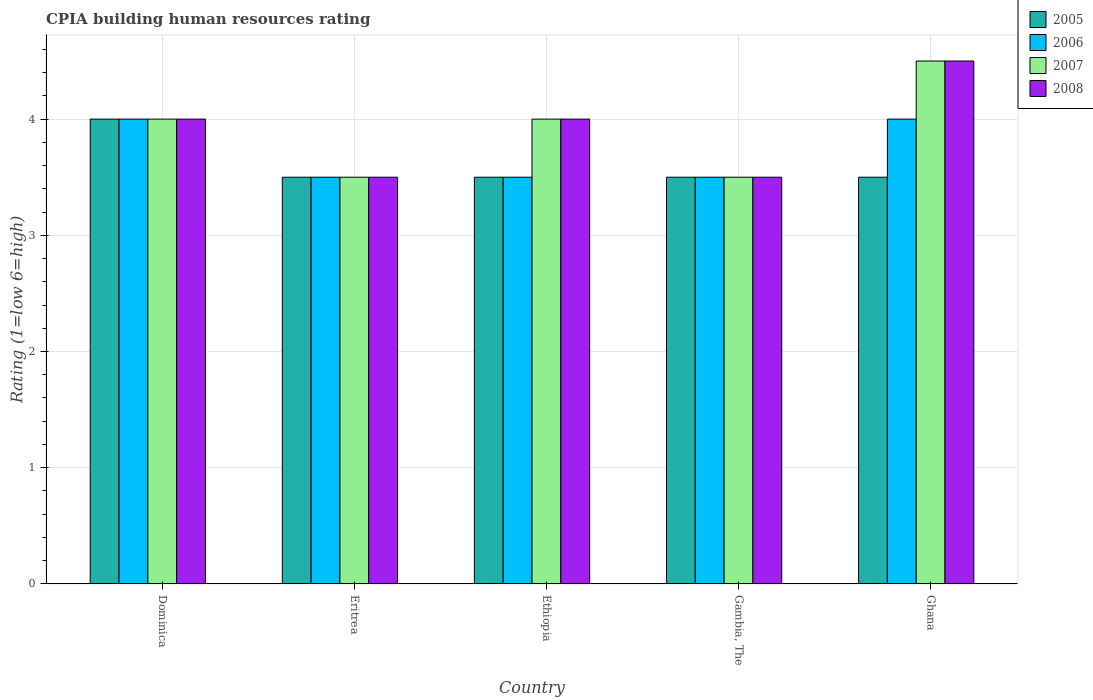Are the number of bars per tick equal to the number of legend labels?
Your answer should be compact. Yes. What is the label of the 5th group of bars from the left?
Provide a short and direct response. Ghana. What is the CPIA rating in 2005 in Ghana?
Give a very brief answer. 3.5. Across all countries, what is the maximum CPIA rating in 2008?
Give a very brief answer. 4.5. Across all countries, what is the minimum CPIA rating in 2005?
Provide a short and direct response. 3.5. In which country was the CPIA rating in 2006 maximum?
Provide a short and direct response. Dominica. In which country was the CPIA rating in 2005 minimum?
Provide a succinct answer. Eritrea. What is the average CPIA rating in 2007 per country?
Offer a terse response. 3.9. What is the difference between the CPIA rating of/in 2006 and CPIA rating of/in 2007 in Eritrea?
Provide a succinct answer. 0. In how many countries, is the CPIA rating in 2006 greater than 2.8?
Provide a succinct answer. 5. What is the ratio of the CPIA rating in 2007 in Ethiopia to that in Ghana?
Your answer should be very brief. 0.89. Is the CPIA rating in 2006 in Dominica less than that in Ghana?
Keep it short and to the point. No. Is the difference between the CPIA rating in 2006 in Ethiopia and Ghana greater than the difference between the CPIA rating in 2007 in Ethiopia and Ghana?
Give a very brief answer. No. What is the difference between the highest and the second highest CPIA rating in 2007?
Your answer should be very brief. 0.5. Is the sum of the CPIA rating in 2005 in Dominica and Ethiopia greater than the maximum CPIA rating in 2008 across all countries?
Make the answer very short. Yes. Is it the case that in every country, the sum of the CPIA rating in 2007 and CPIA rating in 2005 is greater than the sum of CPIA rating in 2006 and CPIA rating in 2008?
Provide a short and direct response. No. What does the 2nd bar from the right in Ghana represents?
Your response must be concise. 2007. Is it the case that in every country, the sum of the CPIA rating in 2006 and CPIA rating in 2005 is greater than the CPIA rating in 2007?
Make the answer very short. Yes. What is the difference between two consecutive major ticks on the Y-axis?
Your response must be concise. 1. Are the values on the major ticks of Y-axis written in scientific E-notation?
Your answer should be compact. No. Does the graph contain any zero values?
Keep it short and to the point. No. How many legend labels are there?
Your answer should be compact. 4. How are the legend labels stacked?
Give a very brief answer. Vertical. What is the title of the graph?
Give a very brief answer. CPIA building human resources rating. Does "1992" appear as one of the legend labels in the graph?
Keep it short and to the point. No. What is the label or title of the X-axis?
Give a very brief answer. Country. What is the Rating (1=low 6=high) of 2006 in Dominica?
Provide a short and direct response. 4. What is the Rating (1=low 6=high) in 2008 in Dominica?
Make the answer very short. 4. What is the Rating (1=low 6=high) in 2005 in Eritrea?
Give a very brief answer. 3.5. What is the Rating (1=low 6=high) of 2008 in Eritrea?
Ensure brevity in your answer.  3.5. What is the Rating (1=low 6=high) of 2005 in Ethiopia?
Your answer should be very brief. 3.5. What is the Rating (1=low 6=high) of 2006 in Ethiopia?
Provide a succinct answer. 3.5. What is the Rating (1=low 6=high) of 2007 in Ethiopia?
Give a very brief answer. 4. What is the Rating (1=low 6=high) of 2008 in Ethiopia?
Your answer should be compact. 4. What is the Rating (1=low 6=high) in 2006 in Ghana?
Offer a terse response. 4. Across all countries, what is the maximum Rating (1=low 6=high) in 2005?
Ensure brevity in your answer.  4. Across all countries, what is the maximum Rating (1=low 6=high) in 2006?
Keep it short and to the point. 4. Across all countries, what is the maximum Rating (1=low 6=high) in 2007?
Ensure brevity in your answer.  4.5. Across all countries, what is the minimum Rating (1=low 6=high) of 2005?
Keep it short and to the point. 3.5. Across all countries, what is the minimum Rating (1=low 6=high) in 2006?
Make the answer very short. 3.5. Across all countries, what is the minimum Rating (1=low 6=high) of 2007?
Keep it short and to the point. 3.5. Across all countries, what is the minimum Rating (1=low 6=high) of 2008?
Your answer should be compact. 3.5. What is the total Rating (1=low 6=high) in 2005 in the graph?
Ensure brevity in your answer.  18. What is the total Rating (1=low 6=high) in 2006 in the graph?
Ensure brevity in your answer.  18.5. What is the total Rating (1=low 6=high) of 2007 in the graph?
Provide a short and direct response. 19.5. What is the total Rating (1=low 6=high) of 2008 in the graph?
Offer a terse response. 19.5. What is the difference between the Rating (1=low 6=high) of 2008 in Dominica and that in Eritrea?
Provide a succinct answer. 0.5. What is the difference between the Rating (1=low 6=high) in 2006 in Dominica and that in Ethiopia?
Offer a terse response. 0.5. What is the difference between the Rating (1=low 6=high) in 2007 in Dominica and that in Ethiopia?
Your response must be concise. 0. What is the difference between the Rating (1=low 6=high) in 2005 in Dominica and that in Gambia, The?
Your answer should be compact. 0.5. What is the difference between the Rating (1=low 6=high) in 2007 in Dominica and that in Gambia, The?
Provide a short and direct response. 0.5. What is the difference between the Rating (1=low 6=high) in 2005 in Dominica and that in Ghana?
Provide a succinct answer. 0.5. What is the difference between the Rating (1=low 6=high) of 2007 in Dominica and that in Ghana?
Your response must be concise. -0.5. What is the difference between the Rating (1=low 6=high) in 2008 in Dominica and that in Ghana?
Make the answer very short. -0.5. What is the difference between the Rating (1=low 6=high) in 2008 in Eritrea and that in Ethiopia?
Ensure brevity in your answer.  -0.5. What is the difference between the Rating (1=low 6=high) in 2005 in Eritrea and that in Ghana?
Ensure brevity in your answer.  0. What is the difference between the Rating (1=low 6=high) in 2006 in Eritrea and that in Ghana?
Your response must be concise. -0.5. What is the difference between the Rating (1=low 6=high) in 2007 in Eritrea and that in Ghana?
Offer a very short reply. -1. What is the difference between the Rating (1=low 6=high) of 2006 in Ethiopia and that in Gambia, The?
Keep it short and to the point. 0. What is the difference between the Rating (1=low 6=high) in 2008 in Ethiopia and that in Gambia, The?
Give a very brief answer. 0.5. What is the difference between the Rating (1=low 6=high) in 2006 in Ethiopia and that in Ghana?
Provide a short and direct response. -0.5. What is the difference between the Rating (1=low 6=high) of 2008 in Ethiopia and that in Ghana?
Ensure brevity in your answer.  -0.5. What is the difference between the Rating (1=low 6=high) in 2006 in Gambia, The and that in Ghana?
Provide a short and direct response. -0.5. What is the difference between the Rating (1=low 6=high) of 2006 in Dominica and the Rating (1=low 6=high) of 2008 in Eritrea?
Keep it short and to the point. 0.5. What is the difference between the Rating (1=low 6=high) in 2005 in Dominica and the Rating (1=low 6=high) in 2007 in Ethiopia?
Provide a short and direct response. 0. What is the difference between the Rating (1=low 6=high) of 2006 in Dominica and the Rating (1=low 6=high) of 2008 in Ethiopia?
Your response must be concise. 0. What is the difference between the Rating (1=low 6=high) of 2007 in Dominica and the Rating (1=low 6=high) of 2008 in Ethiopia?
Keep it short and to the point. 0. What is the difference between the Rating (1=low 6=high) of 2005 in Dominica and the Rating (1=low 6=high) of 2008 in Gambia, The?
Keep it short and to the point. 0.5. What is the difference between the Rating (1=low 6=high) in 2005 in Dominica and the Rating (1=low 6=high) in 2007 in Ghana?
Your answer should be compact. -0.5. What is the difference between the Rating (1=low 6=high) of 2005 in Eritrea and the Rating (1=low 6=high) of 2006 in Ethiopia?
Ensure brevity in your answer.  0. What is the difference between the Rating (1=low 6=high) of 2006 in Eritrea and the Rating (1=low 6=high) of 2007 in Ethiopia?
Keep it short and to the point. -0.5. What is the difference between the Rating (1=low 6=high) in 2006 in Eritrea and the Rating (1=low 6=high) in 2008 in Ethiopia?
Provide a succinct answer. -0.5. What is the difference between the Rating (1=low 6=high) of 2007 in Eritrea and the Rating (1=low 6=high) of 2008 in Ethiopia?
Offer a terse response. -0.5. What is the difference between the Rating (1=low 6=high) in 2006 in Eritrea and the Rating (1=low 6=high) in 2007 in Gambia, The?
Your answer should be compact. 0. What is the difference between the Rating (1=low 6=high) in 2006 in Eritrea and the Rating (1=low 6=high) in 2008 in Gambia, The?
Provide a succinct answer. 0. What is the difference between the Rating (1=low 6=high) of 2005 in Ethiopia and the Rating (1=low 6=high) of 2006 in Gambia, The?
Give a very brief answer. 0. What is the difference between the Rating (1=low 6=high) of 2005 in Ethiopia and the Rating (1=low 6=high) of 2007 in Gambia, The?
Keep it short and to the point. 0. What is the difference between the Rating (1=low 6=high) of 2006 in Ethiopia and the Rating (1=low 6=high) of 2007 in Gambia, The?
Make the answer very short. 0. What is the difference between the Rating (1=low 6=high) of 2006 in Ethiopia and the Rating (1=low 6=high) of 2008 in Gambia, The?
Ensure brevity in your answer.  0. What is the difference between the Rating (1=low 6=high) in 2005 in Ethiopia and the Rating (1=low 6=high) in 2006 in Ghana?
Ensure brevity in your answer.  -0.5. What is the difference between the Rating (1=low 6=high) in 2005 in Ethiopia and the Rating (1=low 6=high) in 2008 in Ghana?
Provide a short and direct response. -1. What is the difference between the Rating (1=low 6=high) in 2006 in Ethiopia and the Rating (1=low 6=high) in 2007 in Ghana?
Your answer should be very brief. -1. What is the difference between the Rating (1=low 6=high) of 2005 in Gambia, The and the Rating (1=low 6=high) of 2007 in Ghana?
Your answer should be very brief. -1. What is the difference between the Rating (1=low 6=high) of 2005 in Gambia, The and the Rating (1=low 6=high) of 2008 in Ghana?
Provide a short and direct response. -1. What is the average Rating (1=low 6=high) of 2005 per country?
Your answer should be very brief. 3.6. What is the difference between the Rating (1=low 6=high) of 2005 and Rating (1=low 6=high) of 2006 in Dominica?
Offer a terse response. 0. What is the difference between the Rating (1=low 6=high) in 2005 and Rating (1=low 6=high) in 2008 in Dominica?
Your answer should be very brief. 0. What is the difference between the Rating (1=low 6=high) in 2007 and Rating (1=low 6=high) in 2008 in Dominica?
Your response must be concise. 0. What is the difference between the Rating (1=low 6=high) in 2005 and Rating (1=low 6=high) in 2006 in Eritrea?
Your answer should be compact. 0. What is the difference between the Rating (1=low 6=high) in 2005 and Rating (1=low 6=high) in 2007 in Eritrea?
Offer a very short reply. 0. What is the difference between the Rating (1=low 6=high) of 2006 and Rating (1=low 6=high) of 2008 in Eritrea?
Keep it short and to the point. 0. What is the difference between the Rating (1=low 6=high) in 2006 and Rating (1=low 6=high) in 2007 in Ethiopia?
Ensure brevity in your answer.  -0.5. What is the difference between the Rating (1=low 6=high) in 2005 and Rating (1=low 6=high) in 2007 in Gambia, The?
Provide a succinct answer. 0. What is the difference between the Rating (1=low 6=high) in 2005 and Rating (1=low 6=high) in 2008 in Gambia, The?
Ensure brevity in your answer.  0. What is the difference between the Rating (1=low 6=high) of 2007 and Rating (1=low 6=high) of 2008 in Gambia, The?
Offer a terse response. 0. What is the difference between the Rating (1=low 6=high) in 2005 and Rating (1=low 6=high) in 2007 in Ghana?
Give a very brief answer. -1. What is the difference between the Rating (1=low 6=high) of 2005 and Rating (1=low 6=high) of 2008 in Ghana?
Make the answer very short. -1. What is the difference between the Rating (1=low 6=high) of 2006 and Rating (1=low 6=high) of 2007 in Ghana?
Your answer should be very brief. -0.5. What is the difference between the Rating (1=low 6=high) in 2006 and Rating (1=low 6=high) in 2008 in Ghana?
Your answer should be very brief. -0.5. What is the ratio of the Rating (1=low 6=high) in 2005 in Dominica to that in Eritrea?
Make the answer very short. 1.14. What is the ratio of the Rating (1=low 6=high) of 2006 in Dominica to that in Eritrea?
Provide a short and direct response. 1.14. What is the ratio of the Rating (1=low 6=high) in 2005 in Dominica to that in Ethiopia?
Provide a short and direct response. 1.14. What is the ratio of the Rating (1=low 6=high) of 2008 in Dominica to that in Ethiopia?
Offer a terse response. 1. What is the ratio of the Rating (1=low 6=high) in 2006 in Dominica to that in Gambia, The?
Keep it short and to the point. 1.14. What is the ratio of the Rating (1=low 6=high) in 2008 in Dominica to that in Gambia, The?
Provide a succinct answer. 1.14. What is the ratio of the Rating (1=low 6=high) of 2005 in Dominica to that in Ghana?
Your answer should be very brief. 1.14. What is the ratio of the Rating (1=low 6=high) in 2006 in Dominica to that in Ghana?
Make the answer very short. 1. What is the ratio of the Rating (1=low 6=high) in 2008 in Dominica to that in Ghana?
Your answer should be very brief. 0.89. What is the ratio of the Rating (1=low 6=high) in 2005 in Eritrea to that in Gambia, The?
Make the answer very short. 1. What is the ratio of the Rating (1=low 6=high) in 2006 in Eritrea to that in Gambia, The?
Your response must be concise. 1. What is the ratio of the Rating (1=low 6=high) of 2008 in Eritrea to that in Gambia, The?
Offer a very short reply. 1. What is the ratio of the Rating (1=low 6=high) of 2005 in Eritrea to that in Ghana?
Make the answer very short. 1. What is the ratio of the Rating (1=low 6=high) of 2008 in Eritrea to that in Ghana?
Your answer should be very brief. 0.78. What is the ratio of the Rating (1=low 6=high) in 2005 in Ethiopia to that in Gambia, The?
Your response must be concise. 1. What is the ratio of the Rating (1=low 6=high) of 2005 in Ethiopia to that in Ghana?
Offer a very short reply. 1. What is the ratio of the Rating (1=low 6=high) in 2007 in Ethiopia to that in Ghana?
Keep it short and to the point. 0.89. What is the ratio of the Rating (1=low 6=high) in 2007 in Gambia, The to that in Ghana?
Your answer should be very brief. 0.78. What is the ratio of the Rating (1=low 6=high) of 2008 in Gambia, The to that in Ghana?
Ensure brevity in your answer.  0.78. What is the difference between the highest and the second highest Rating (1=low 6=high) in 2006?
Ensure brevity in your answer.  0. What is the difference between the highest and the second highest Rating (1=low 6=high) in 2007?
Your answer should be compact. 0.5. What is the difference between the highest and the lowest Rating (1=low 6=high) of 2005?
Ensure brevity in your answer.  0.5. What is the difference between the highest and the lowest Rating (1=low 6=high) of 2007?
Offer a very short reply. 1. What is the difference between the highest and the lowest Rating (1=low 6=high) in 2008?
Offer a very short reply. 1. 